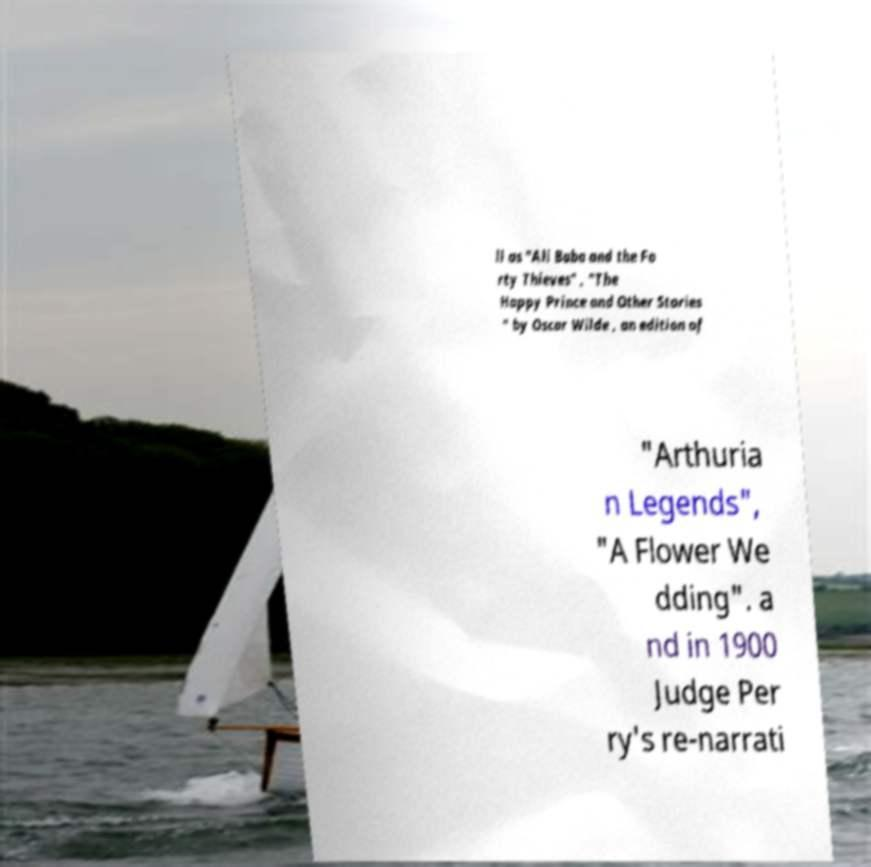Can you accurately transcribe the text from the provided image for me? ll as "Ali Baba and the Fo rty Thieves" , "The Happy Prince and Other Stories " by Oscar Wilde , an edition of "Arthuria n Legends", "A Flower We dding". a nd in 1900 Judge Per ry's re-narrati 